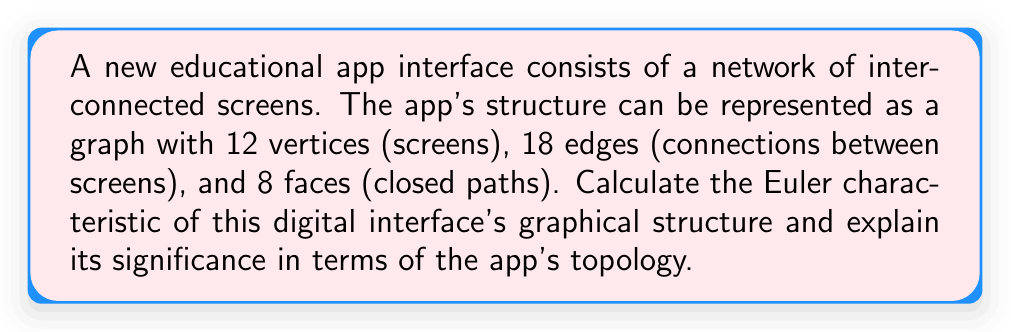Help me with this question. To solve this problem, we'll follow these steps:

1. Recall the Euler characteristic formula:
   $$\chi = V - E + F$$
   Where:
   $\chi$ = Euler characteristic
   $V$ = Number of vertices
   $E$ = Number of edges
   $F$ = Number of faces

2. Substitute the given values:
   $V = 12$ (screens)
   $E = 18$ (connections)
   $F = 8$ (closed paths)

3. Calculate the Euler characteristic:
   $$\chi = 12 - 18 + 8 = 2$$

4. Interpret the result:
   The Euler characteristic of 2 indicates that the app's interface structure is topologically equivalent to a sphere. This means:

   a) The interface is connected and has no "holes" in its structure.
   b) It can be continuously deformed into a sphere without changing its topological properties.
   c) The app's navigation is likely intuitive and well-structured, as all screens are interconnected without unnecessary complexity.

5. Significance for the tech foundation:
   This topological analysis demonstrates that the app has a solid, well-organized structure. It suggests that users can navigate through all screens efficiently, which is crucial for educational technology. The spherical topology also implies that the app's structure is flexible and can be easily modified or expanded without disrupting its overall organization.
Answer: The Euler characteristic of the digital interface's graphical structure is 2, indicating a spherical topology that is beneficial for educational app design and user navigation. 